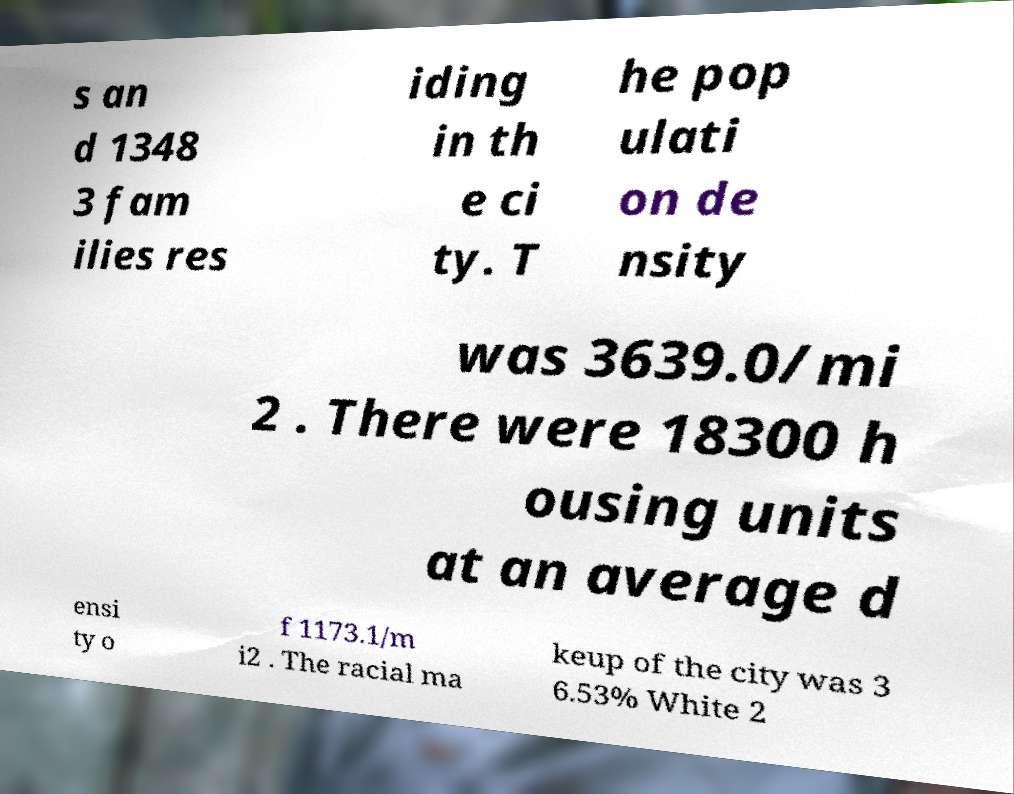I need the written content from this picture converted into text. Can you do that? s an d 1348 3 fam ilies res iding in th e ci ty. T he pop ulati on de nsity was 3639.0/mi 2 . There were 18300 h ousing units at an average d ensi ty o f 1173.1/m i2 . The racial ma keup of the city was 3 6.53% White 2 